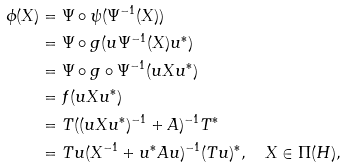Convert formula to latex. <formula><loc_0><loc_0><loc_500><loc_500>\phi ( X ) & = \Psi \circ \psi ( \Psi ^ { - 1 } ( X ) ) \\ & = \Psi \circ g ( u \Psi ^ { - 1 } ( X ) u ^ { * } ) \\ & = \Psi \circ g \circ \Psi ^ { - 1 } ( u X u ^ { * } ) \\ & = f ( u X u ^ { \ast } ) \\ & = T ( ( u X u ^ { \ast } ) ^ { - 1 } + A ) ^ { - 1 } T ^ { \ast } \\ & = T u ( X ^ { - 1 } + u ^ { \ast } A u ) ^ { - 1 } ( T u ) ^ { \ast } , \quad X \in \Pi ( H ) ,</formula> 